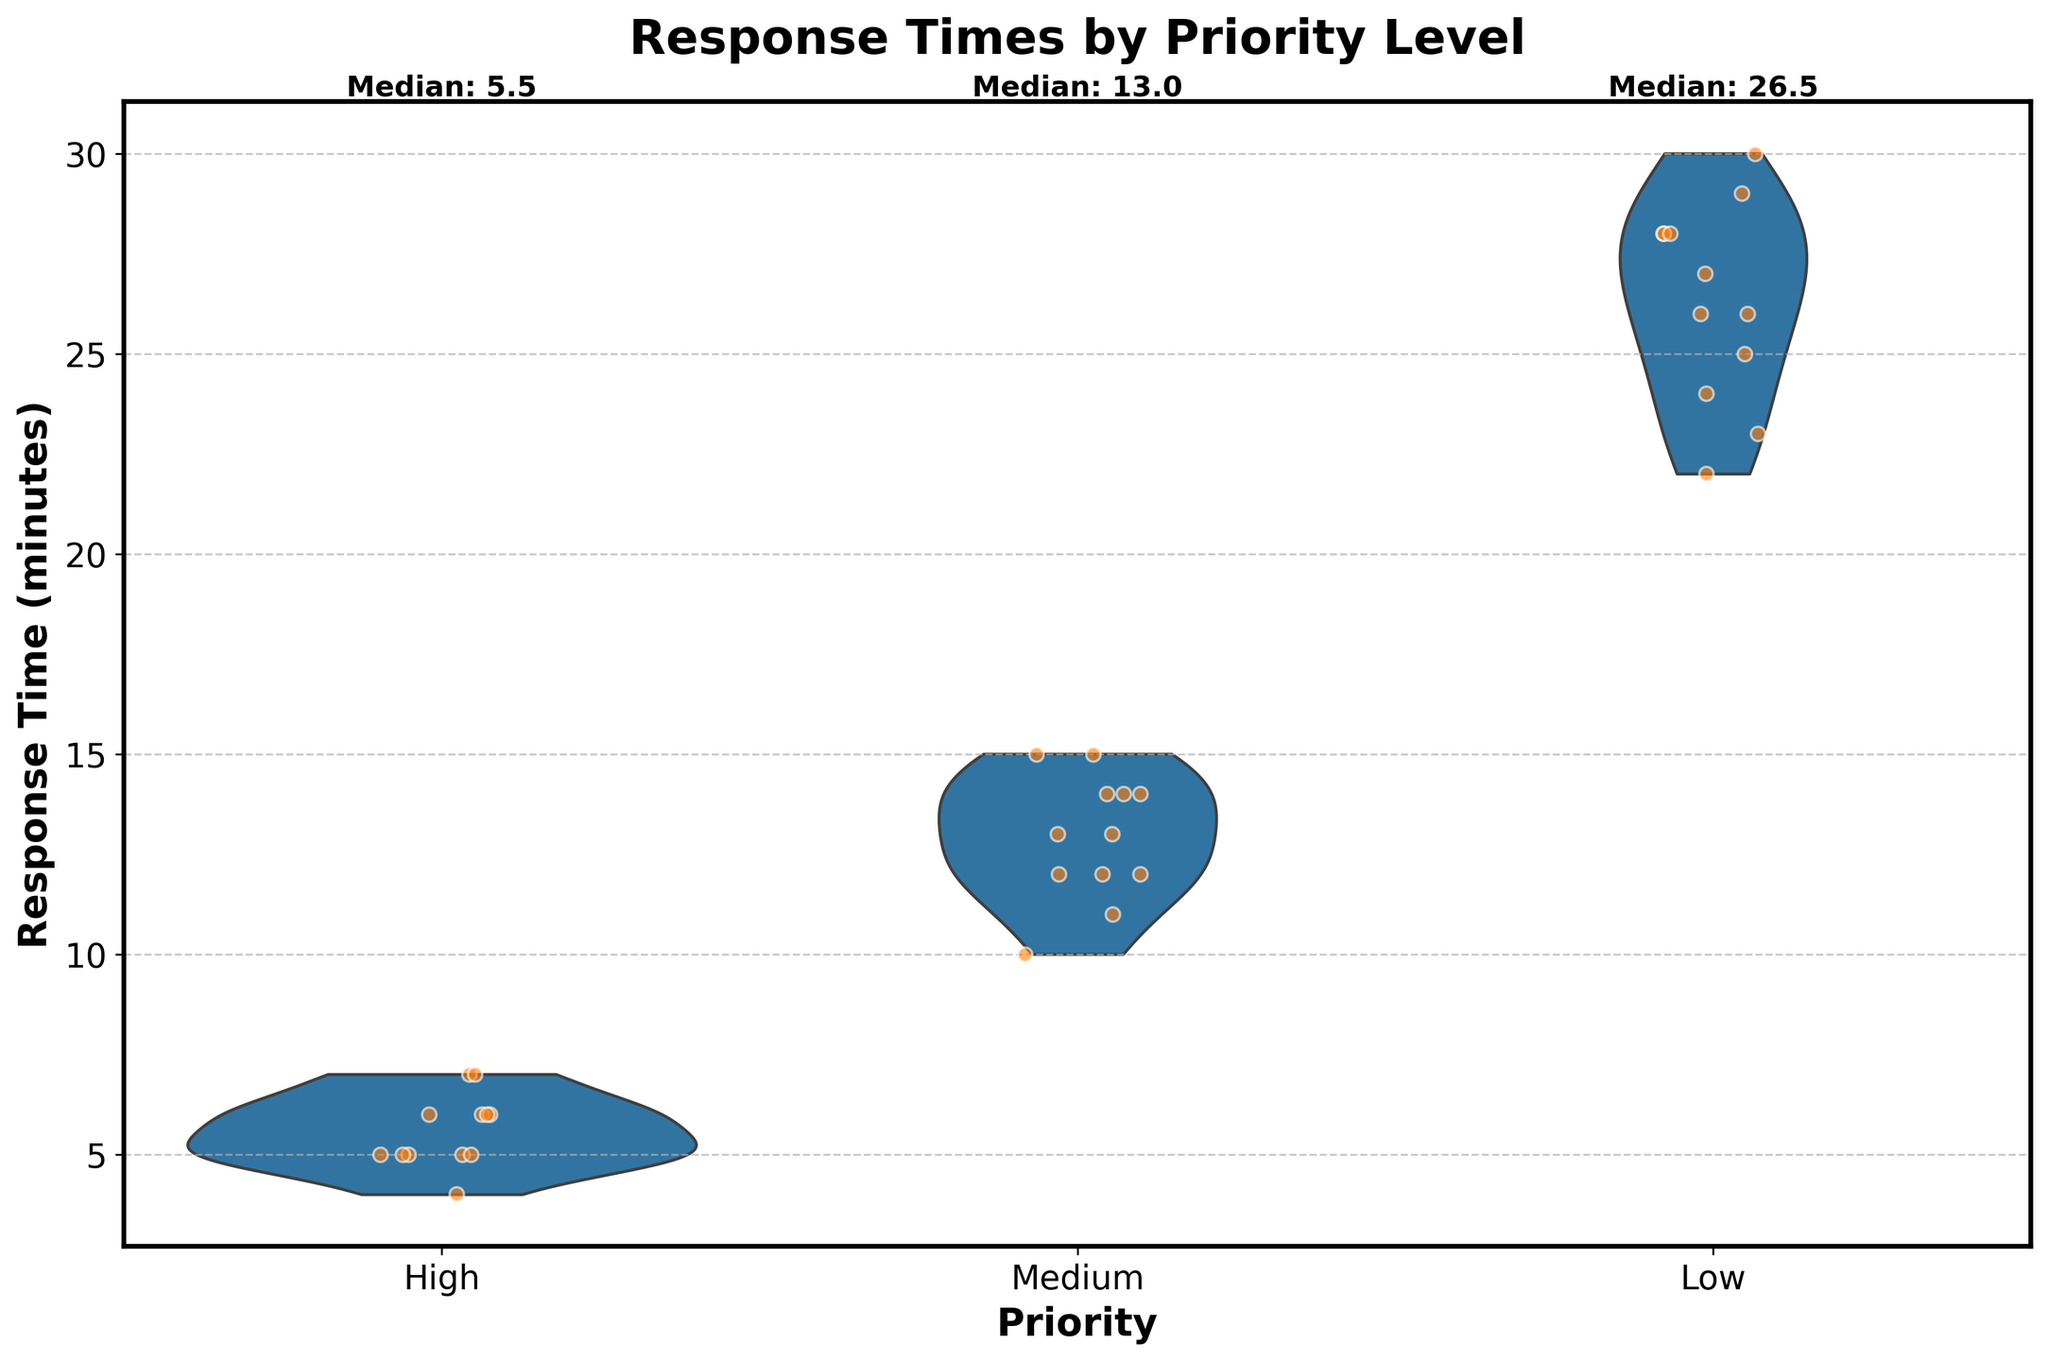What is the title of the plot? The title is usually displayed at the top of the figure, summarizing its content. Here, it is written in bold, larger font at the top of the figure.
Answer: Response Times by Priority Level What are the three priority levels represented in the plot? The priority levels are indicated on the x-axis of the figure. Each level is labeled below its respective violin and jittered points.
Answer: High, Medium, Low Which priority level has the most consistent response times? Consistency can be inferred by examining the spread of the violin plot and the jittered points. The narrower the spread, the more consistent the response times.
Answer: High What is the median response time for 'Low' priority requests? The plot includes text annotations above each violin plot, indicating the median. For ‘Low’ priority, the annotation is found above the third violin.
Answer: 26.5 Compare the median response times of 'High' and 'Medium' priorities. Which one is higher? Median values are annotated above each category. By comparing these values, we can see which one is higher.
Answer: Medium What is the range of response times for 'Medium' priority requests? The range can be determined by observing the extent of the violin plot for 'Medium' priority, from the lowest to the highest point.
Answer: 10 to 15 How does the number of data points for 'High' priority compare to those for 'Low' priority? Compare the number of jittered points (individual dots) within each violin plot for 'High' and 'Low' priorities. Each dot represents a data point.
Answer: High has fewer data points than Low Which priority level displays the highest variability in response times? Variability is shown by the width and spread of the violin plot. The category with the widest and most spread-out violin plot indicates the highest variability.
Answer: Low What is the mode response time for 'High' priority requests? Mode refers to the most frequently occurring value. For 'High' priority, look at the jittered points clustered together; the most common point value is the mode.
Answer: 5 What do the colors of the violin plots represent? The colors differentiate between the priority levels. By observing the figure, we can see that different colors are used for 'High', 'Medium', and 'Low' priorities.
Answer: Different priority levels 